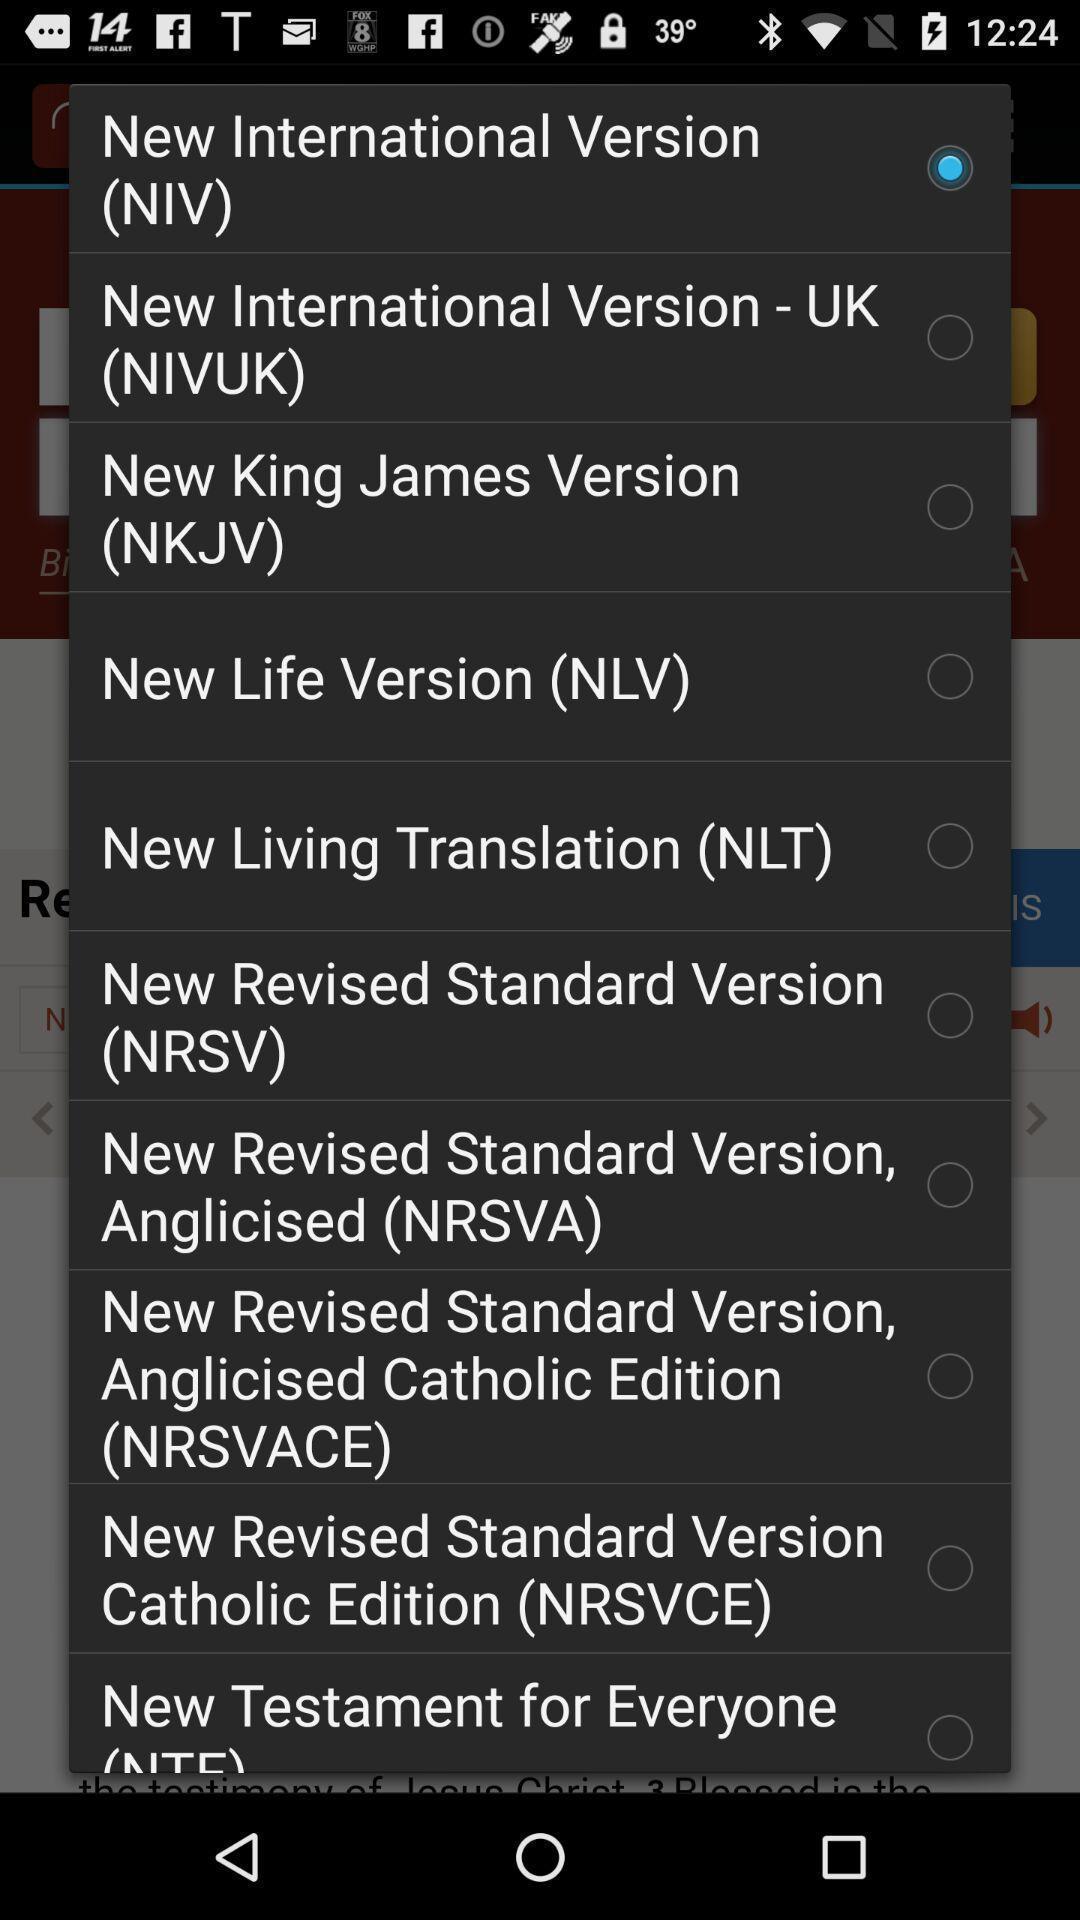Give me a narrative description of this picture. Pop up page showing the various options. 